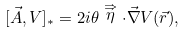Convert formula to latex. <formula><loc_0><loc_0><loc_500><loc_500>[ \vec { A } , V ] _ { \ast } = 2 i \theta \stackrel { \Rightarrow } { \eta } \cdot \vec { \nabla } V ( \vec { r } ) ,</formula> 